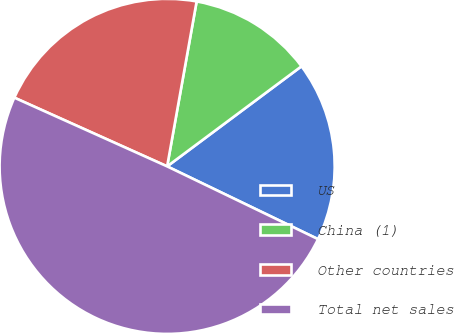<chart> <loc_0><loc_0><loc_500><loc_500><pie_chart><fcel>US<fcel>China (1)<fcel>Other countries<fcel>Total net sales<nl><fcel>17.34%<fcel>11.99%<fcel>21.09%<fcel>49.57%<nl></chart> 